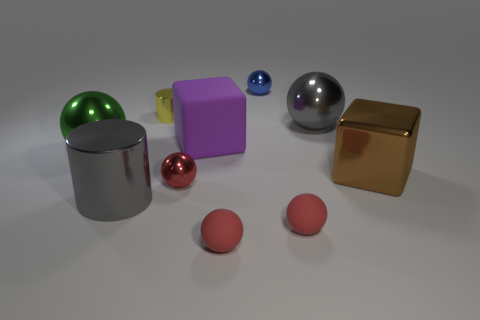What number of other objects are the same material as the gray ball?
Your response must be concise. 6. Are the small sphere that is to the left of the large matte block and the large purple block made of the same material?
Provide a short and direct response. No. Is the number of large objects left of the small blue object greater than the number of small red metal objects on the right side of the small red shiny thing?
Provide a succinct answer. Yes. How many objects are either large gray metal objects to the right of the big shiny cylinder or small green objects?
Keep it short and to the point. 1. The gray object that is made of the same material as the big cylinder is what shape?
Provide a short and direct response. Sphere. The ball that is both on the right side of the tiny blue object and in front of the big matte thing is what color?
Ensure brevity in your answer.  Red. How many cylinders are big rubber objects or blue metal objects?
Give a very brief answer. 0. What number of metallic objects have the same size as the brown cube?
Provide a short and direct response. 3. What number of green spheres are in front of the big gray shiny thing in front of the large green metal thing?
Your response must be concise. 0. There is a metal thing that is behind the big metal cylinder and in front of the brown object; what is its size?
Offer a very short reply. Small. 